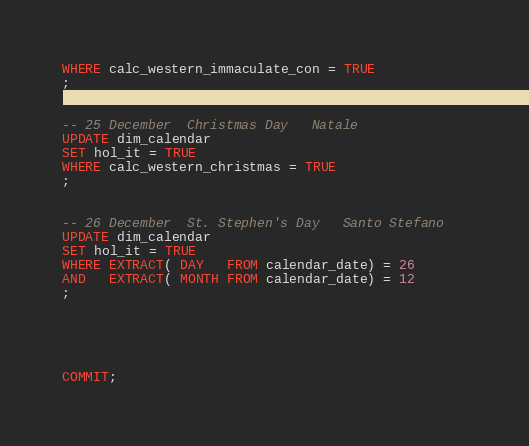Convert code to text. <code><loc_0><loc_0><loc_500><loc_500><_SQL_>WHERE calc_western_immaculate_con = TRUE
; 


-- 25 December	Christmas Day	Natale	
UPDATE dim_calendar
SET hol_it = TRUE
WHERE calc_western_christmas = TRUE
; 


-- 26 December	St. Stephen's Day	Santo Stefano	
UPDATE dim_calendar
SET hol_it = TRUE
WHERE EXTRACT( DAY   FROM calendar_date) = 26
AND   EXTRACT( MONTH FROM calendar_date) = 12
; 





COMMIT;
</code> 